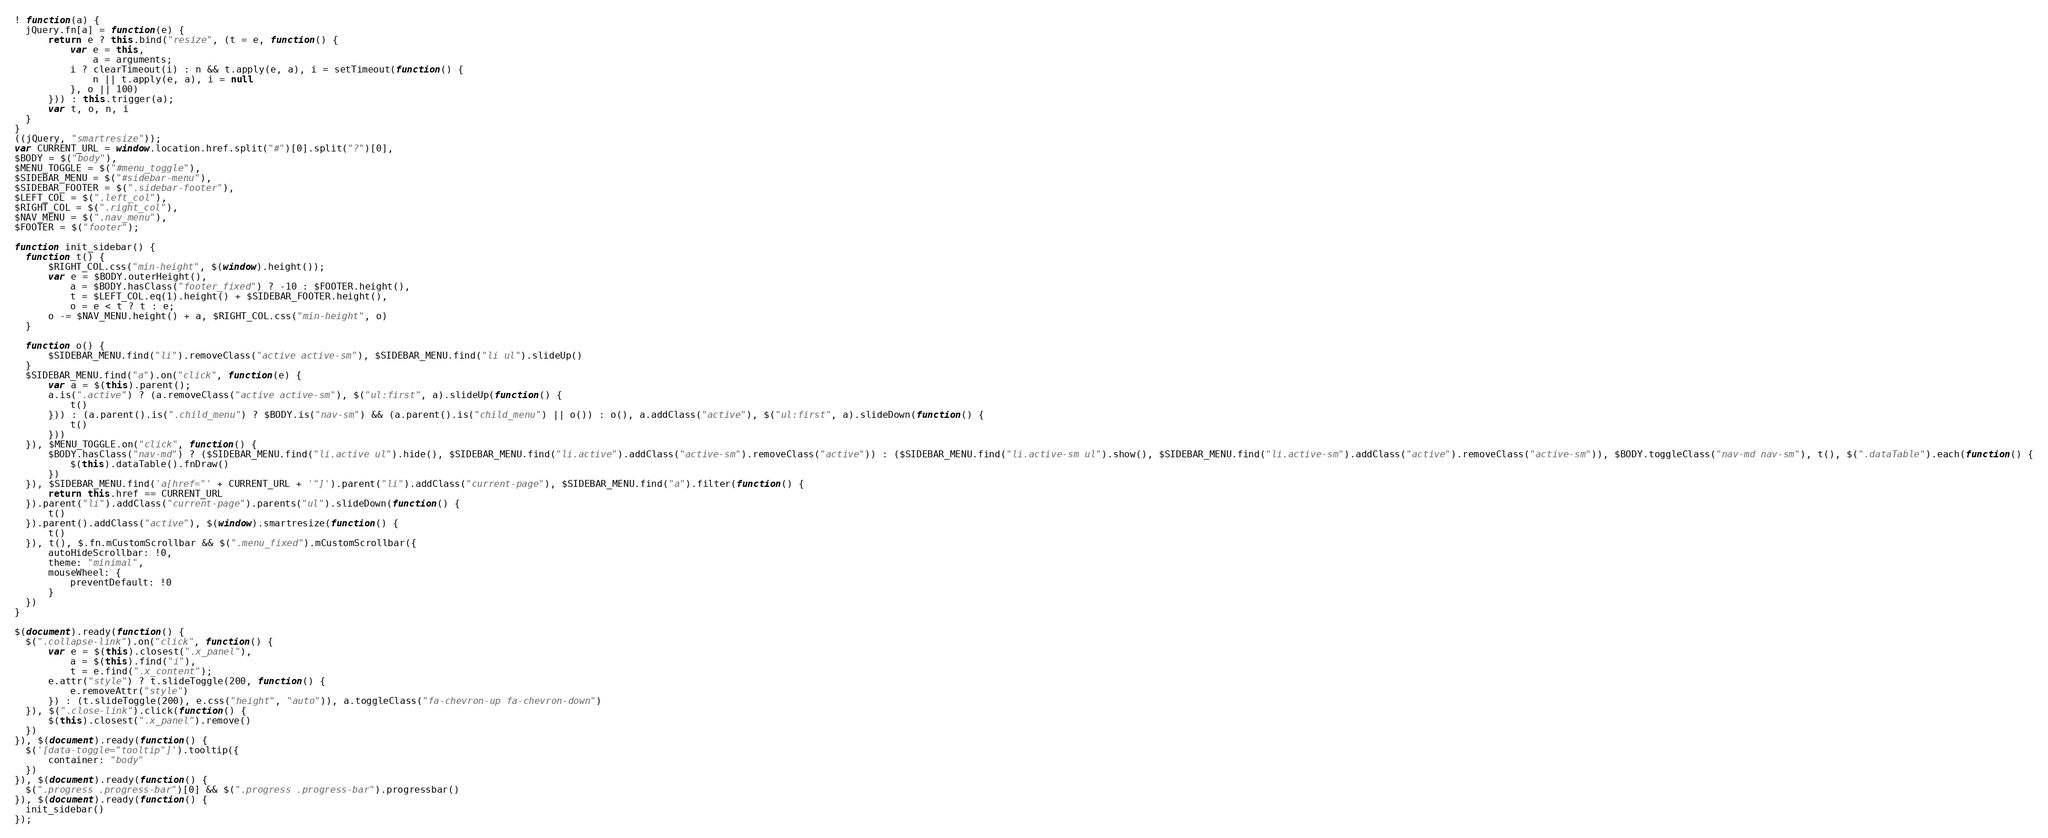<code> <loc_0><loc_0><loc_500><loc_500><_JavaScript_>! function(a) {
  jQuery.fn[a] = function(e) {
      return e ? this.bind("resize", (t = e, function() {
          var e = this,
              a = arguments;
          i ? clearTimeout(i) : n && t.apply(e, a), i = setTimeout(function() {
              n || t.apply(e, a), i = null
          }, o || 100)
      })) : this.trigger(a);
      var t, o, n, i
  }
}
((jQuery, "smartresize"));
var CURRENT_URL = window.location.href.split("#")[0].split("?")[0],
$BODY = $("body"),
$MENU_TOGGLE = $("#menu_toggle"),
$SIDEBAR_MENU = $("#sidebar-menu"),
$SIDEBAR_FOOTER = $(".sidebar-footer"),
$LEFT_COL = $(".left_col"),
$RIGHT_COL = $(".right_col"),
$NAV_MENU = $(".nav_menu"),
$FOOTER = $("footer");

function init_sidebar() {
  function t() {
      $RIGHT_COL.css("min-height", $(window).height());
      var e = $BODY.outerHeight(),
          a = $BODY.hasClass("footer_fixed") ? -10 : $FOOTER.height(),
          t = $LEFT_COL.eq(1).height() + $SIDEBAR_FOOTER.height(),
          o = e < t ? t : e;
      o -= $NAV_MENU.height() + a, $RIGHT_COL.css("min-height", o)
  }

  function o() {
      $SIDEBAR_MENU.find("li").removeClass("active active-sm"), $SIDEBAR_MENU.find("li ul").slideUp()
  }
  $SIDEBAR_MENU.find("a").on("click", function(e) {
      var a = $(this).parent();
      a.is(".active") ? (a.removeClass("active active-sm"), $("ul:first", a).slideUp(function() {
          t()
      })) : (a.parent().is(".child_menu") ? $BODY.is("nav-sm") && (a.parent().is("child_menu") || o()) : o(), a.addClass("active"), $("ul:first", a).slideDown(function() {
          t()
      }))
  }), $MENU_TOGGLE.on("click", function() {
      $BODY.hasClass("nav-md") ? ($SIDEBAR_MENU.find("li.active ul").hide(), $SIDEBAR_MENU.find("li.active").addClass("active-sm").removeClass("active")) : ($SIDEBAR_MENU.find("li.active-sm ul").show(), $SIDEBAR_MENU.find("li.active-sm").addClass("active").removeClass("active-sm")), $BODY.toggleClass("nav-md nav-sm"), t(), $(".dataTable").each(function() {
          $(this).dataTable().fnDraw()
      })
  }), $SIDEBAR_MENU.find('a[href="' + CURRENT_URL + '"]').parent("li").addClass("current-page"), $SIDEBAR_MENU.find("a").filter(function() {
      return this.href == CURRENT_URL
  }).parent("li").addClass("current-page").parents("ul").slideDown(function() {
      t()
  }).parent().addClass("active"), $(window).smartresize(function() {
      t()
  }), t(), $.fn.mCustomScrollbar && $(".menu_fixed").mCustomScrollbar({
      autoHideScrollbar: !0,
      theme: "minimal",
      mouseWheel: {
          preventDefault: !0
      }
  })
}

$(document).ready(function() {
  $(".collapse-link").on("click", function() {
      var e = $(this).closest(".x_panel"),
          a = $(this).find("i"),
          t = e.find(".x_content");
      e.attr("style") ? t.slideToggle(200, function() {
          e.removeAttr("style")
      }) : (t.slideToggle(200), e.css("height", "auto")), a.toggleClass("fa-chevron-up fa-chevron-down")
  }), $(".close-link").click(function() {
      $(this).closest(".x_panel").remove()
  })
}), $(document).ready(function() {
  $('[data-toggle="tooltip"]').tooltip({
      container: "body"
  })
}), $(document).ready(function() {
  $(".progress .progress-bar")[0] && $(".progress .progress-bar").progressbar()
}), $(document).ready(function() {
  init_sidebar()
});</code> 